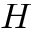<formula> <loc_0><loc_0><loc_500><loc_500>H</formula> 